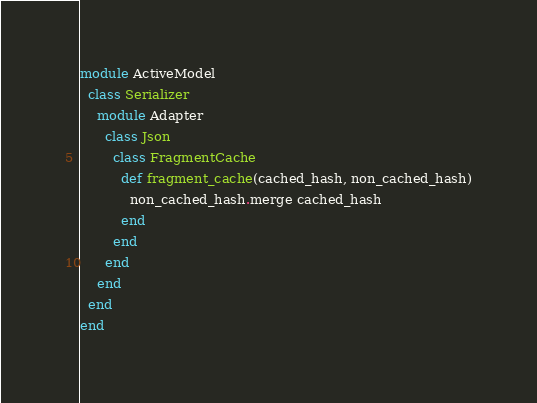<code> <loc_0><loc_0><loc_500><loc_500><_Ruby_>module ActiveModel
  class Serializer
    module Adapter
      class Json
        class FragmentCache
          def fragment_cache(cached_hash, non_cached_hash)
            non_cached_hash.merge cached_hash
          end
        end
      end
    end
  end
end
</code> 